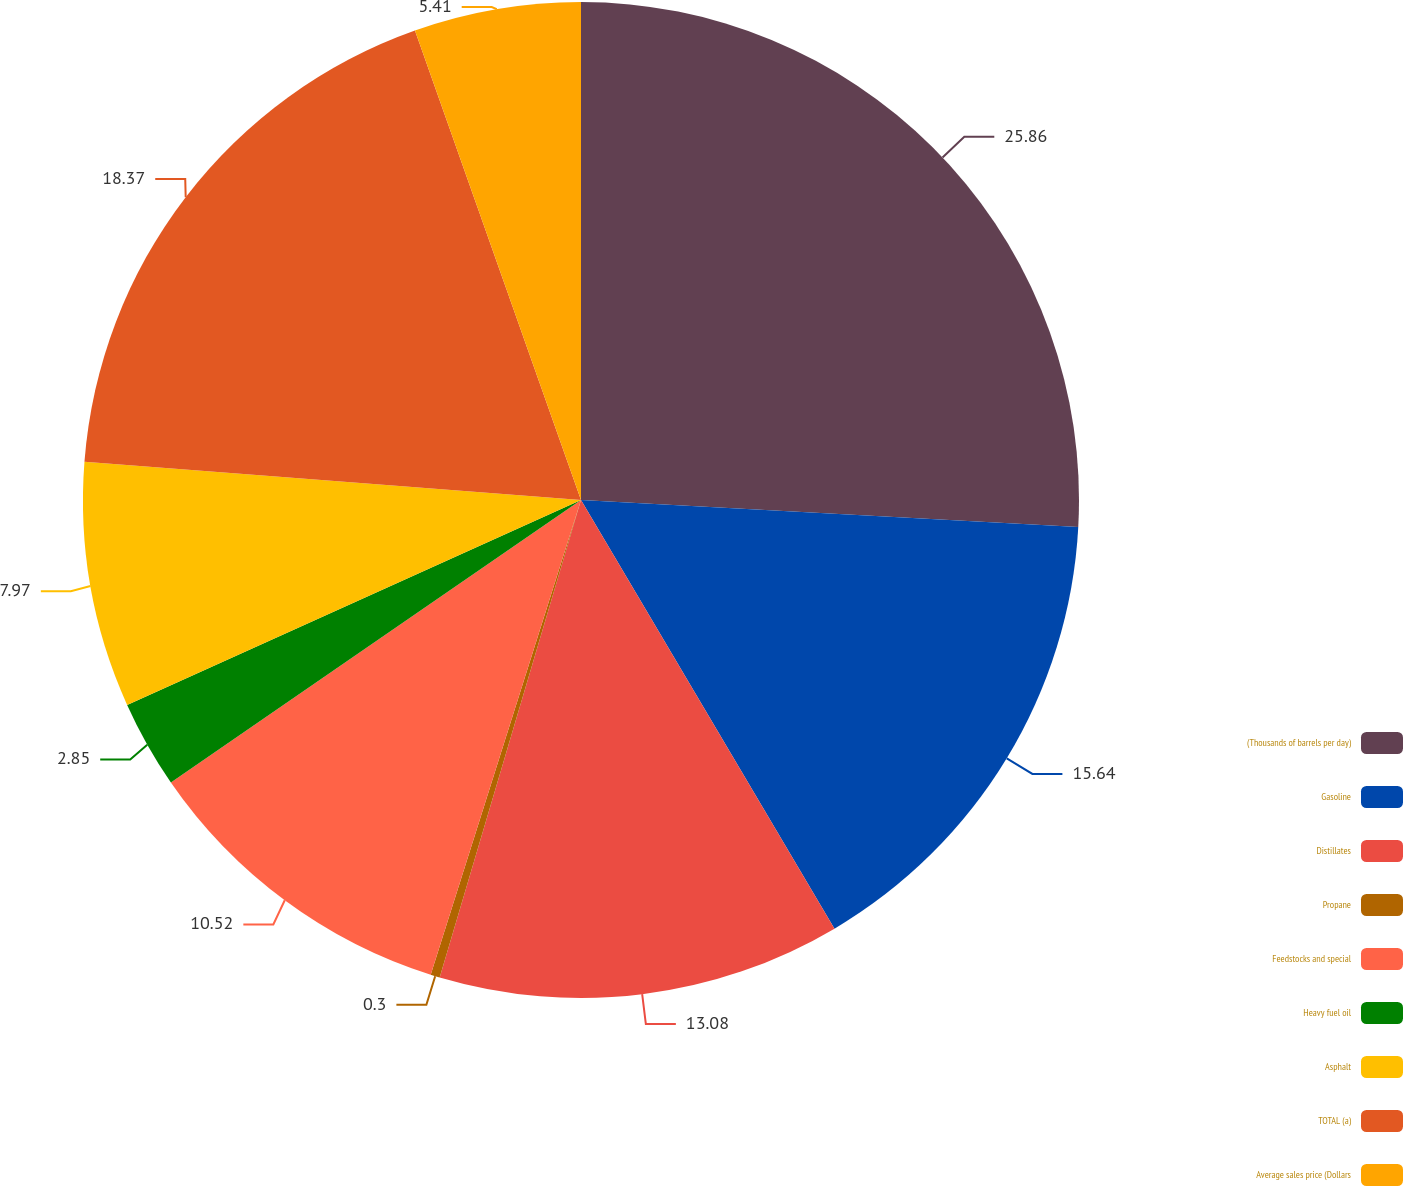Convert chart. <chart><loc_0><loc_0><loc_500><loc_500><pie_chart><fcel>(Thousands of barrels per day)<fcel>Gasoline<fcel>Distillates<fcel>Propane<fcel>Feedstocks and special<fcel>Heavy fuel oil<fcel>Asphalt<fcel>TOTAL (a)<fcel>Average sales price (Dollars<nl><fcel>25.86%<fcel>15.64%<fcel>13.08%<fcel>0.3%<fcel>10.52%<fcel>2.85%<fcel>7.97%<fcel>18.37%<fcel>5.41%<nl></chart> 